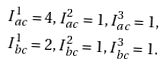Convert formula to latex. <formula><loc_0><loc_0><loc_500><loc_500>I _ { a c } ^ { 1 } = 4 , I _ { a c } ^ { 2 } = 1 , I _ { a c } ^ { 3 } = 1 , \\ I _ { b c } ^ { 1 } = 2 , I _ { b c } ^ { 2 } = 1 , I _ { b c } ^ { 3 } = 1 .</formula> 